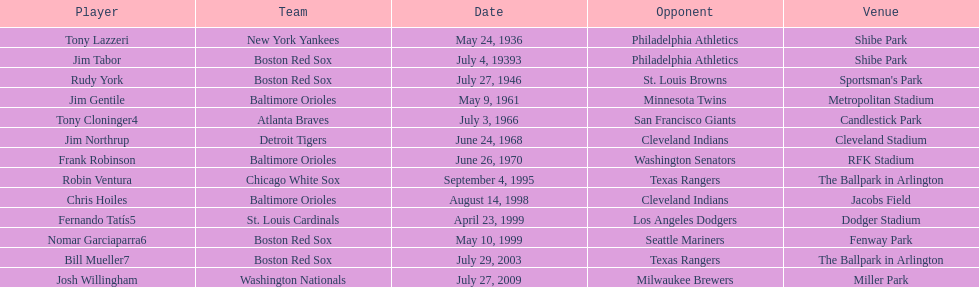How many instances have a boston red sox player achieved two grand slams in a single match? 4. 